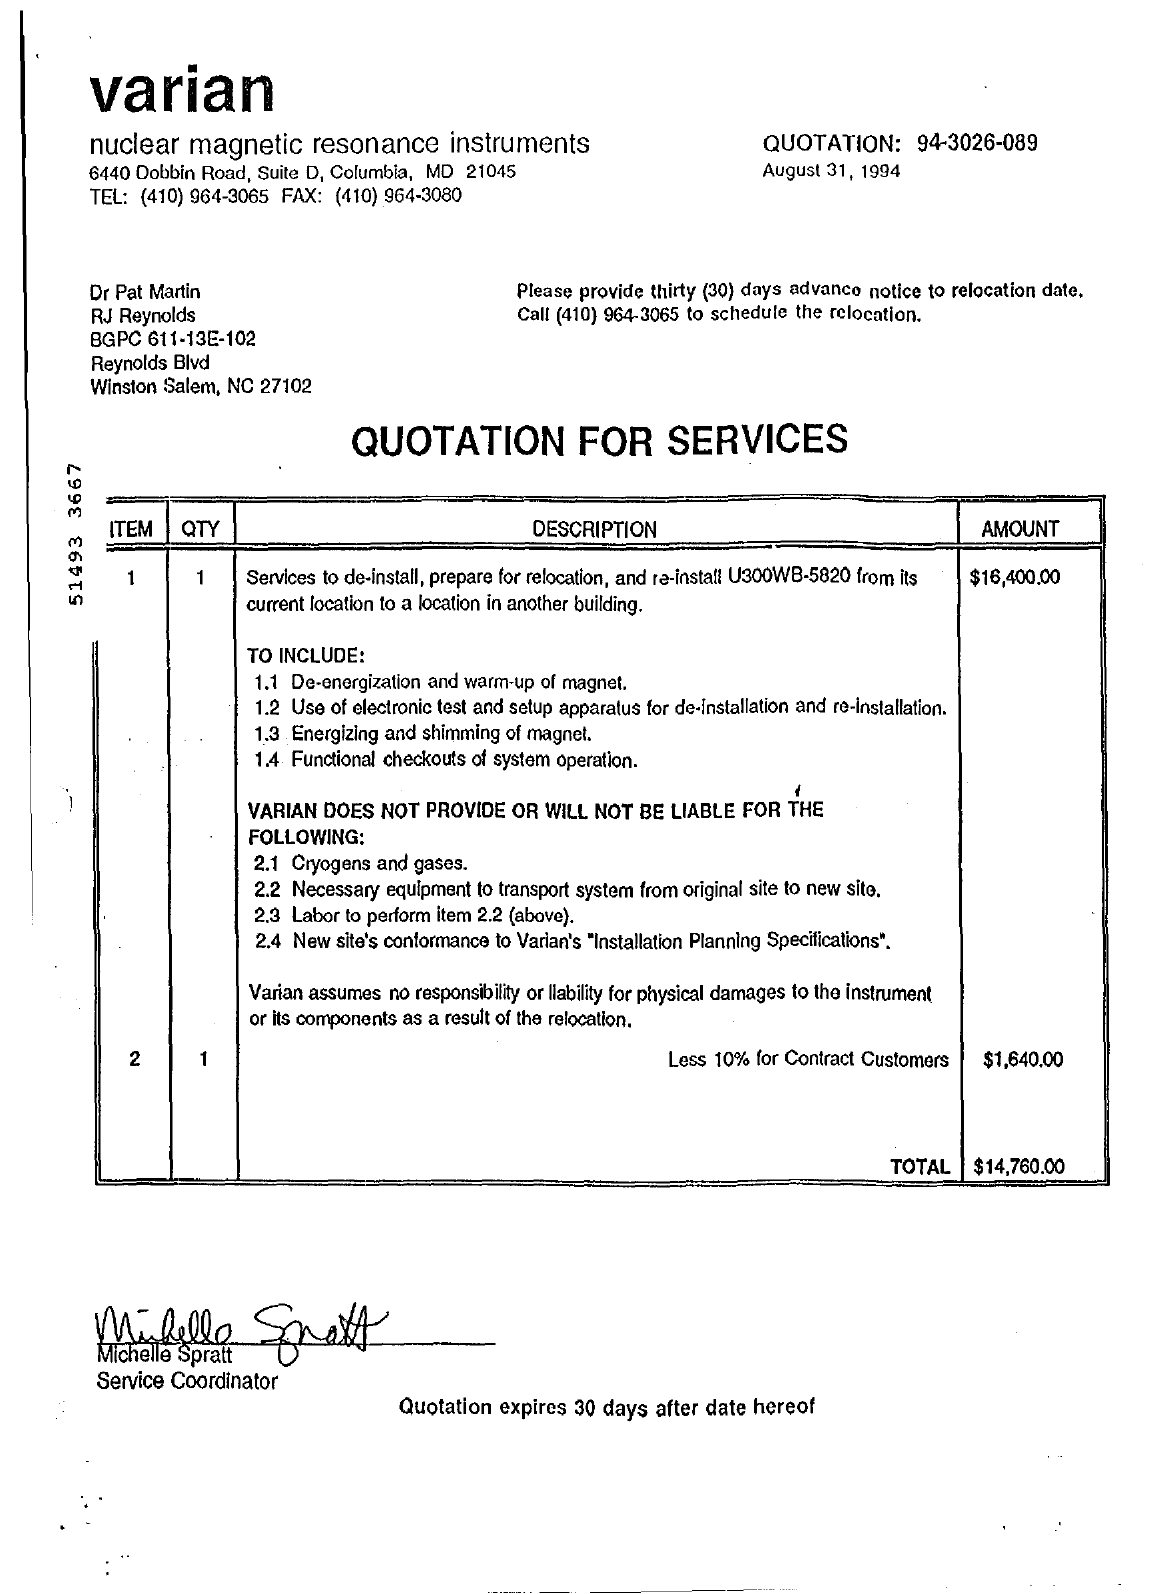Indicate a few pertinent items in this graphic. The total cost of relocation is $14,760.00. 